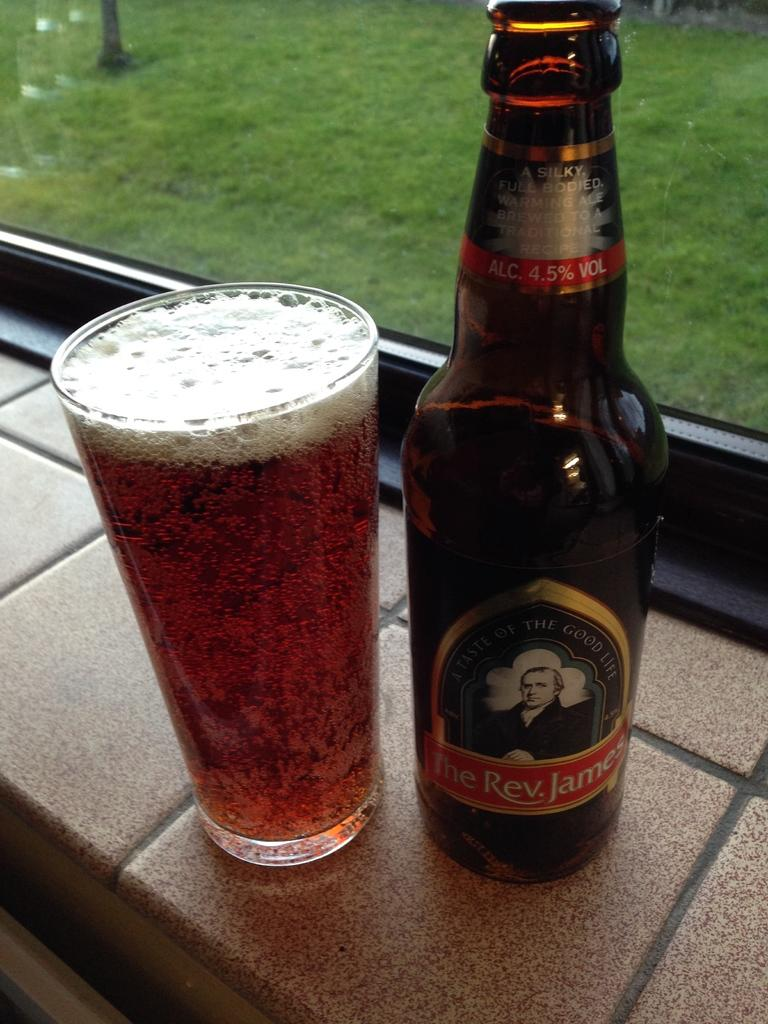<image>
Create a compact narrative representing the image presented. A glass of beer poured from a bottle of The Rev. James is next to a window. 